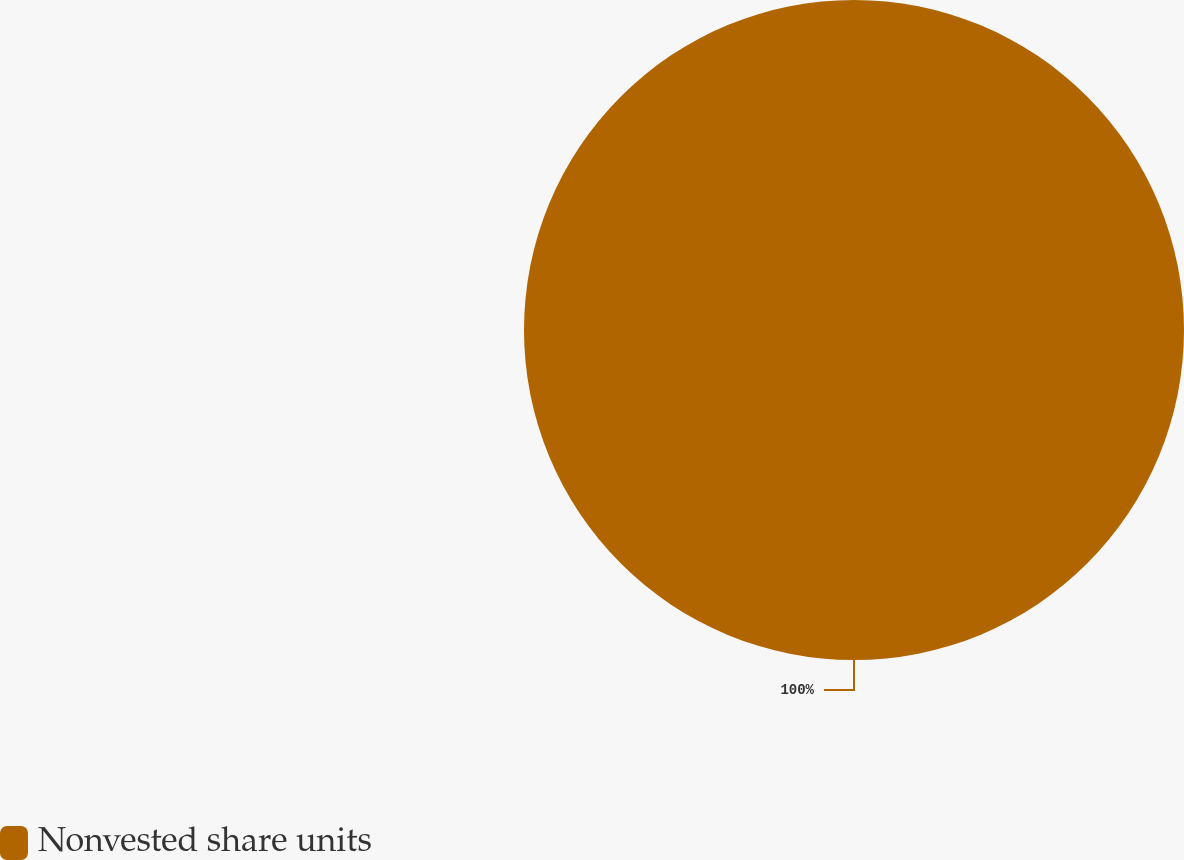<chart> <loc_0><loc_0><loc_500><loc_500><pie_chart><fcel>Nonvested share units<nl><fcel>100.0%<nl></chart> 